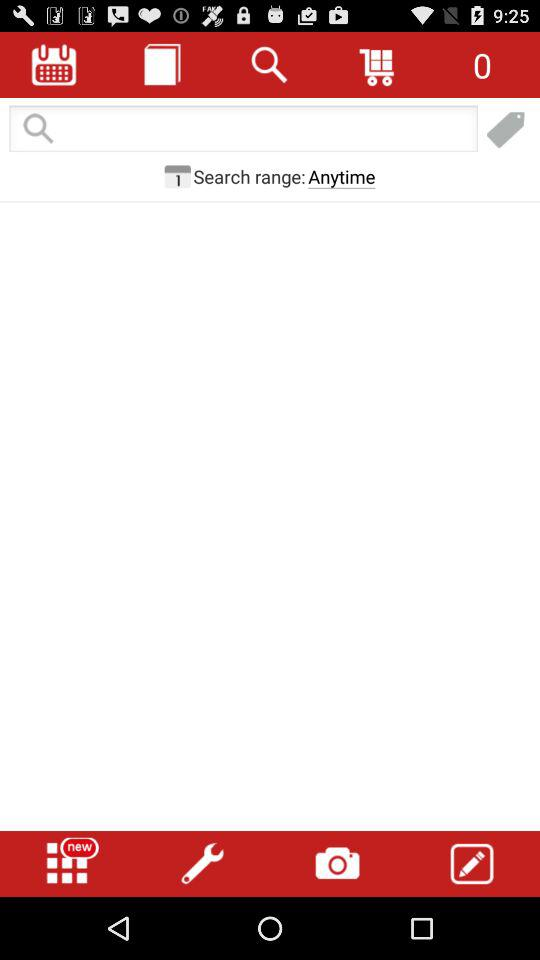What is the selected option for the search range? The selected option for the search range is "Anytime". 